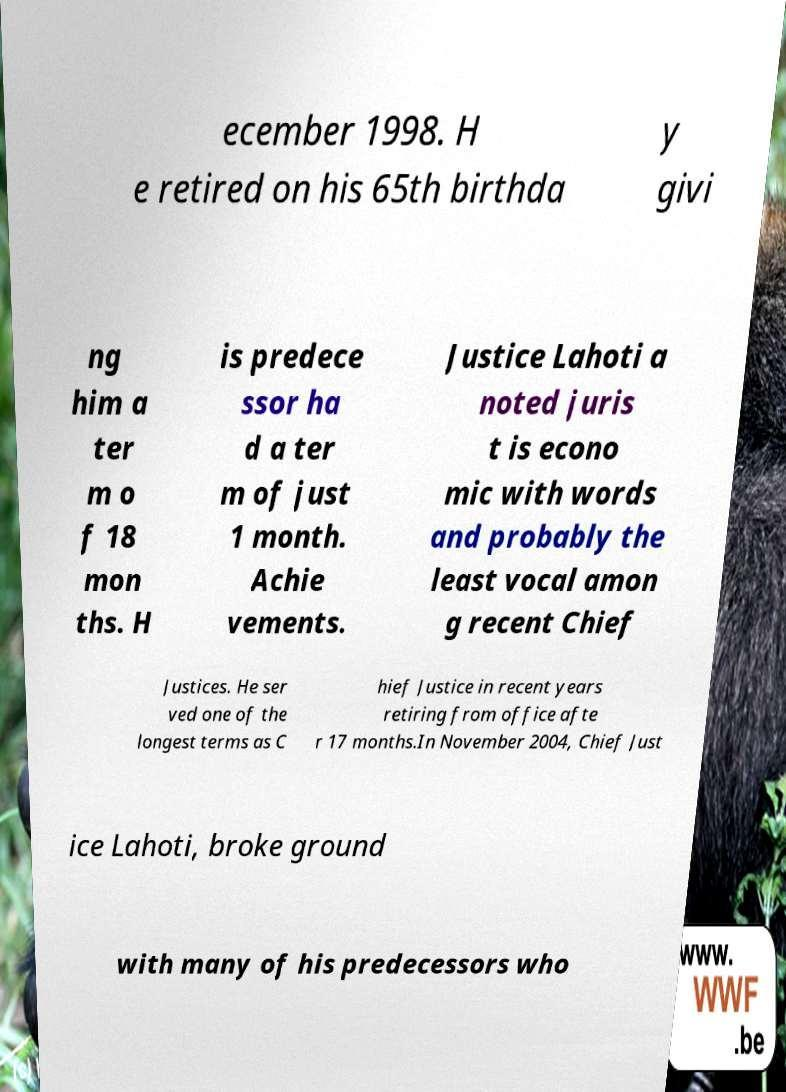There's text embedded in this image that I need extracted. Can you transcribe it verbatim? ecember 1998. H e retired on his 65th birthda y givi ng him a ter m o f 18 mon ths. H is predece ssor ha d a ter m of just 1 month. Achie vements. Justice Lahoti a noted juris t is econo mic with words and probably the least vocal amon g recent Chief Justices. He ser ved one of the longest terms as C hief Justice in recent years retiring from office afte r 17 months.In November 2004, Chief Just ice Lahoti, broke ground with many of his predecessors who 